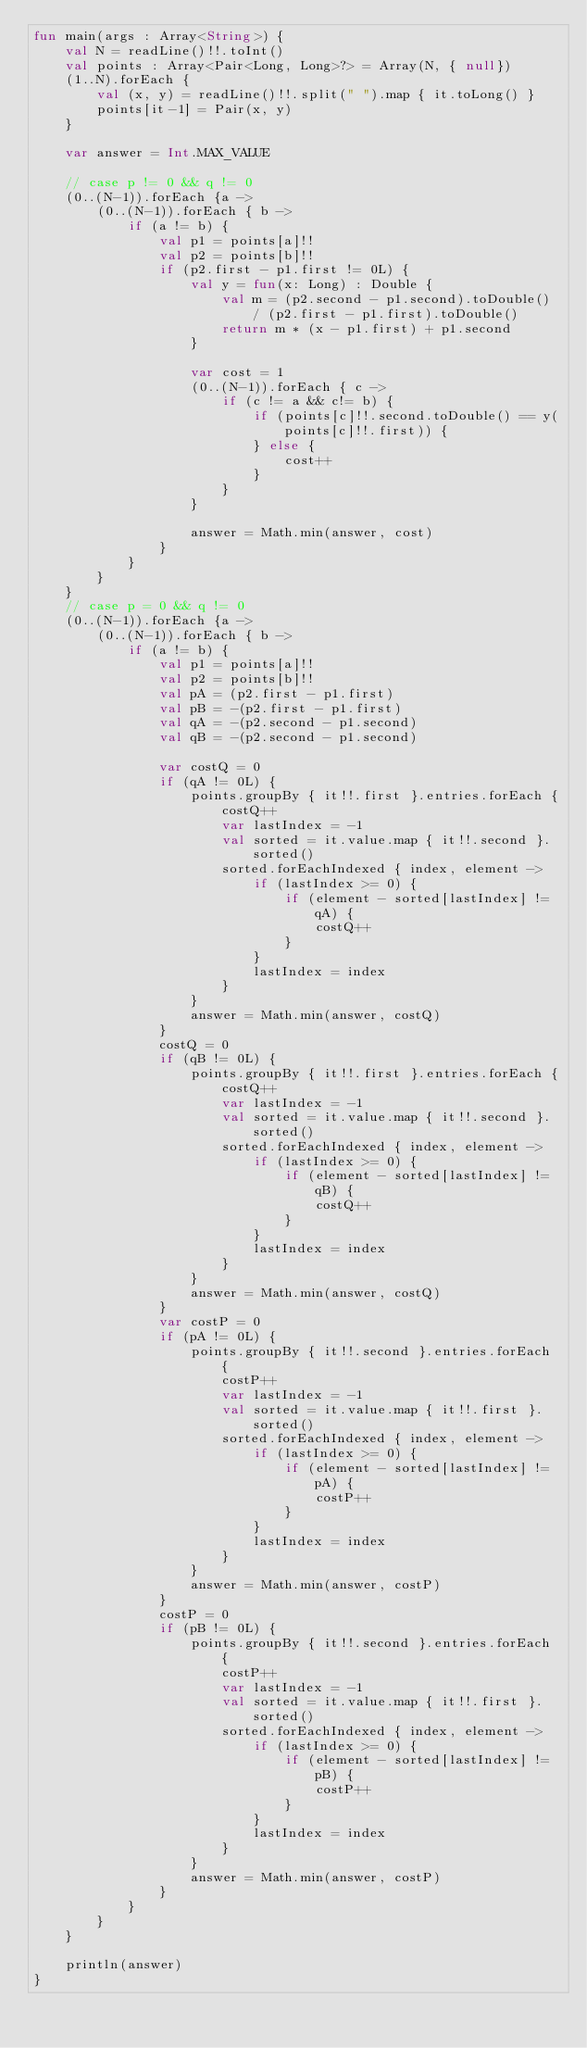<code> <loc_0><loc_0><loc_500><loc_500><_Kotlin_>fun main(args : Array<String>) {
    val N = readLine()!!.toInt()
    val points : Array<Pair<Long, Long>?> = Array(N, { null})
    (1..N).forEach {
        val (x, y) = readLine()!!.split(" ").map { it.toLong() }
        points[it-1] = Pair(x, y)
    }

    var answer = Int.MAX_VALUE

    // case p != 0 && q != 0
    (0..(N-1)).forEach {a ->
        (0..(N-1)).forEach { b ->
            if (a != b) {
                val p1 = points[a]!!
                val p2 = points[b]!!
                if (p2.first - p1.first != 0L) {
                    val y = fun(x: Long) : Double {
                        val m = (p2.second - p1.second).toDouble() / (p2.first - p1.first).toDouble()
                        return m * (x - p1.first) + p1.second
                    }

                    var cost = 1
                    (0..(N-1)).forEach { c ->
                        if (c != a && c!= b) {
                            if (points[c]!!.second.toDouble() == y(points[c]!!.first)) {
                            } else {
                                cost++
                            }
                        }
                    }

                    answer = Math.min(answer, cost)
                }
            }
        }
    }
    // case p = 0 && q != 0
    (0..(N-1)).forEach {a ->
        (0..(N-1)).forEach { b ->
            if (a != b) {
                val p1 = points[a]!!
                val p2 = points[b]!!
                val pA = (p2.first - p1.first)
                val pB = -(p2.first - p1.first)
                val qA = -(p2.second - p1.second)
                val qB = -(p2.second - p1.second)

                var costQ = 0
                if (qA != 0L) {
                    points.groupBy { it!!.first }.entries.forEach {
                        costQ++
                        var lastIndex = -1
                        val sorted = it.value.map { it!!.second }.sorted()
                        sorted.forEachIndexed { index, element ->
                            if (lastIndex >= 0) {
                                if (element - sorted[lastIndex] != qA) {
                                    costQ++
                                }
                            }
                            lastIndex = index
                        }
                    }
                    answer = Math.min(answer, costQ)
                }
                costQ = 0
                if (qB != 0L) {
                    points.groupBy { it!!.first }.entries.forEach {
                        costQ++
                        var lastIndex = -1
                        val sorted = it.value.map { it!!.second }.sorted()
                        sorted.forEachIndexed { index, element ->
                            if (lastIndex >= 0) {
                                if (element - sorted[lastIndex] != qB) {
                                    costQ++
                                }
                            }
                            lastIndex = index
                        }
                    }
                    answer = Math.min(answer, costQ)
                }
                var costP = 0
                if (pA != 0L) {
                    points.groupBy { it!!.second }.entries.forEach {
                        costP++
                        var lastIndex = -1
                        val sorted = it.value.map { it!!.first }.sorted()
                        sorted.forEachIndexed { index, element ->
                            if (lastIndex >= 0) {
                                if (element - sorted[lastIndex] != pA) {
                                    costP++
                                }
                            }
                            lastIndex = index
                        }
                    }
                    answer = Math.min(answer, costP)
                }
                costP = 0
                if (pB != 0L) {
                    points.groupBy { it!!.second }.entries.forEach {
                        costP++
                        var lastIndex = -1
                        val sorted = it.value.map { it!!.first }.sorted()
                        sorted.forEachIndexed { index, element ->
                            if (lastIndex >= 0) {
                                if (element - sorted[lastIndex] != pB) {
                                    costP++
                                }
                            }
                            lastIndex = index
                        }
                    }
                    answer = Math.min(answer, costP)
                }
            }
        }
    }

    println(answer)
}</code> 